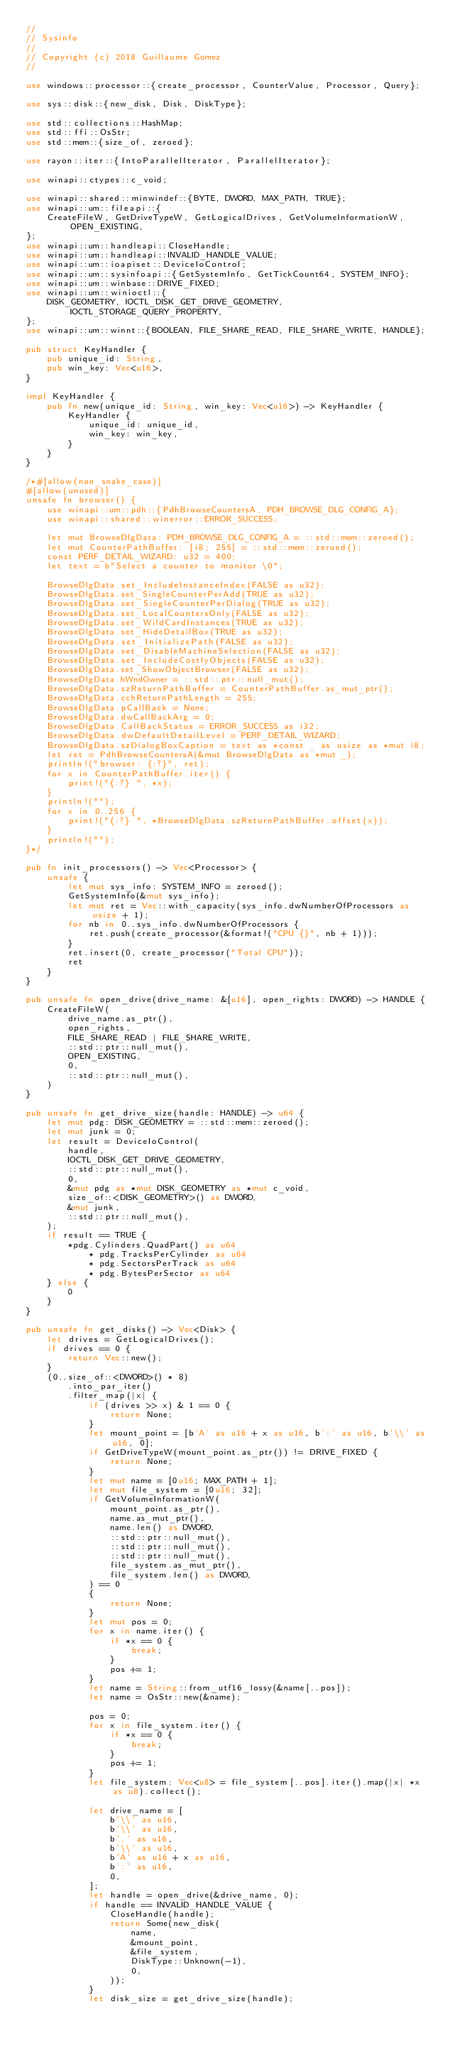<code> <loc_0><loc_0><loc_500><loc_500><_Rust_>//
// Sysinfo
//
// Copyright (c) 2018 Guillaume Gomez
//

use windows::processor::{create_processor, CounterValue, Processor, Query};

use sys::disk::{new_disk, Disk, DiskType};

use std::collections::HashMap;
use std::ffi::OsStr;
use std::mem::{size_of, zeroed};

use rayon::iter::{IntoParallelIterator, ParallelIterator};

use winapi::ctypes::c_void;

use winapi::shared::minwindef::{BYTE, DWORD, MAX_PATH, TRUE};
use winapi::um::fileapi::{
    CreateFileW, GetDriveTypeW, GetLogicalDrives, GetVolumeInformationW, OPEN_EXISTING,
};
use winapi::um::handleapi::CloseHandle;
use winapi::um::handleapi::INVALID_HANDLE_VALUE;
use winapi::um::ioapiset::DeviceIoControl;
use winapi::um::sysinfoapi::{GetSystemInfo, GetTickCount64, SYSTEM_INFO};
use winapi::um::winbase::DRIVE_FIXED;
use winapi::um::winioctl::{
    DISK_GEOMETRY, IOCTL_DISK_GET_DRIVE_GEOMETRY, IOCTL_STORAGE_QUERY_PROPERTY,
};
use winapi::um::winnt::{BOOLEAN, FILE_SHARE_READ, FILE_SHARE_WRITE, HANDLE};

pub struct KeyHandler {
    pub unique_id: String,
    pub win_key: Vec<u16>,
}

impl KeyHandler {
    pub fn new(unique_id: String, win_key: Vec<u16>) -> KeyHandler {
        KeyHandler {
            unique_id: unique_id,
            win_key: win_key,
        }
    }
}

/*#[allow(non_snake_case)]
#[allow(unused)]
unsafe fn browser() {
    use winapi::um::pdh::{PdhBrowseCountersA, PDH_BROWSE_DLG_CONFIG_A};
    use winapi::shared::winerror::ERROR_SUCCESS;

    let mut BrowseDlgData: PDH_BROWSE_DLG_CONFIG_A = ::std::mem::zeroed();
    let mut CounterPathBuffer: [i8; 255] = ::std::mem::zeroed();
    const PERF_DETAIL_WIZARD: u32 = 400;
    let text = b"Select a counter to monitor.\0";

    BrowseDlgData.set_IncludeInstanceIndex(FALSE as u32);
    BrowseDlgData.set_SingleCounterPerAdd(TRUE as u32);
    BrowseDlgData.set_SingleCounterPerDialog(TRUE as u32);
    BrowseDlgData.set_LocalCountersOnly(FALSE as u32);
    BrowseDlgData.set_WildCardInstances(TRUE as u32);
    BrowseDlgData.set_HideDetailBox(TRUE as u32);
    BrowseDlgData.set_InitializePath(FALSE as u32);
    BrowseDlgData.set_DisableMachineSelection(FALSE as u32);
    BrowseDlgData.set_IncludeCostlyObjects(FALSE as u32);
    BrowseDlgData.set_ShowObjectBrowser(FALSE as u32);
    BrowseDlgData.hWndOwner = ::std::ptr::null_mut();
    BrowseDlgData.szReturnPathBuffer = CounterPathBuffer.as_mut_ptr();
    BrowseDlgData.cchReturnPathLength = 255;
    BrowseDlgData.pCallBack = None;
    BrowseDlgData.dwCallBackArg = 0;
    BrowseDlgData.CallBackStatus = ERROR_SUCCESS as i32;
    BrowseDlgData.dwDefaultDetailLevel = PERF_DETAIL_WIZARD;
    BrowseDlgData.szDialogBoxCaption = text as *const _ as usize as *mut i8;
    let ret = PdhBrowseCountersA(&mut BrowseDlgData as *mut _);
    println!("browser: {:?}", ret);
    for x in CounterPathBuffer.iter() {
        print!("{:?} ", *x);
    }
    println!("");
    for x in 0..256 {
        print!("{:?} ", *BrowseDlgData.szReturnPathBuffer.offset(x));
    }
    println!("");
}*/

pub fn init_processors() -> Vec<Processor> {
    unsafe {
        let mut sys_info: SYSTEM_INFO = zeroed();
        GetSystemInfo(&mut sys_info);
        let mut ret = Vec::with_capacity(sys_info.dwNumberOfProcessors as usize + 1);
        for nb in 0..sys_info.dwNumberOfProcessors {
            ret.push(create_processor(&format!("CPU {}", nb + 1)));
        }
        ret.insert(0, create_processor("Total CPU"));
        ret
    }
}

pub unsafe fn open_drive(drive_name: &[u16], open_rights: DWORD) -> HANDLE {
    CreateFileW(
        drive_name.as_ptr(),
        open_rights,
        FILE_SHARE_READ | FILE_SHARE_WRITE,
        ::std::ptr::null_mut(),
        OPEN_EXISTING,
        0,
        ::std::ptr::null_mut(),
    )
}

pub unsafe fn get_drive_size(handle: HANDLE) -> u64 {
    let mut pdg: DISK_GEOMETRY = ::std::mem::zeroed();
    let mut junk = 0;
    let result = DeviceIoControl(
        handle,
        IOCTL_DISK_GET_DRIVE_GEOMETRY,
        ::std::ptr::null_mut(),
        0,
        &mut pdg as *mut DISK_GEOMETRY as *mut c_void,
        size_of::<DISK_GEOMETRY>() as DWORD,
        &mut junk,
        ::std::ptr::null_mut(),
    );
    if result == TRUE {
        *pdg.Cylinders.QuadPart() as u64
            * pdg.TracksPerCylinder as u64
            * pdg.SectorsPerTrack as u64
            * pdg.BytesPerSector as u64
    } else {
        0
    }
}

pub unsafe fn get_disks() -> Vec<Disk> {
    let drives = GetLogicalDrives();
    if drives == 0 {
        return Vec::new();
    }
    (0..size_of::<DWORD>() * 8)
        .into_par_iter()
        .filter_map(|x| {
            if (drives >> x) & 1 == 0 {
                return None;
            }
            let mount_point = [b'A' as u16 + x as u16, b':' as u16, b'\\' as u16, 0];
            if GetDriveTypeW(mount_point.as_ptr()) != DRIVE_FIXED {
                return None;
            }
            let mut name = [0u16; MAX_PATH + 1];
            let mut file_system = [0u16; 32];
            if GetVolumeInformationW(
                mount_point.as_ptr(),
                name.as_mut_ptr(),
                name.len() as DWORD,
                ::std::ptr::null_mut(),
                ::std::ptr::null_mut(),
                ::std::ptr::null_mut(),
                file_system.as_mut_ptr(),
                file_system.len() as DWORD,
            ) == 0
            {
                return None;
            }
            let mut pos = 0;
            for x in name.iter() {
                if *x == 0 {
                    break;
                }
                pos += 1;
            }
            let name = String::from_utf16_lossy(&name[..pos]);
            let name = OsStr::new(&name);

            pos = 0;
            for x in file_system.iter() {
                if *x == 0 {
                    break;
                }
                pos += 1;
            }
            let file_system: Vec<u8> = file_system[..pos].iter().map(|x| *x as u8).collect();

            let drive_name = [
                b'\\' as u16,
                b'\\' as u16,
                b'.' as u16,
                b'\\' as u16,
                b'A' as u16 + x as u16,
                b':' as u16,
                0,
            ];
            let handle = open_drive(&drive_name, 0);
            if handle == INVALID_HANDLE_VALUE {
                CloseHandle(handle);
                return Some(new_disk(
                    name,
                    &mount_point,
                    &file_system,
                    DiskType::Unknown(-1),
                    0,
                ));
            }
            let disk_size = get_drive_size(handle);</code> 